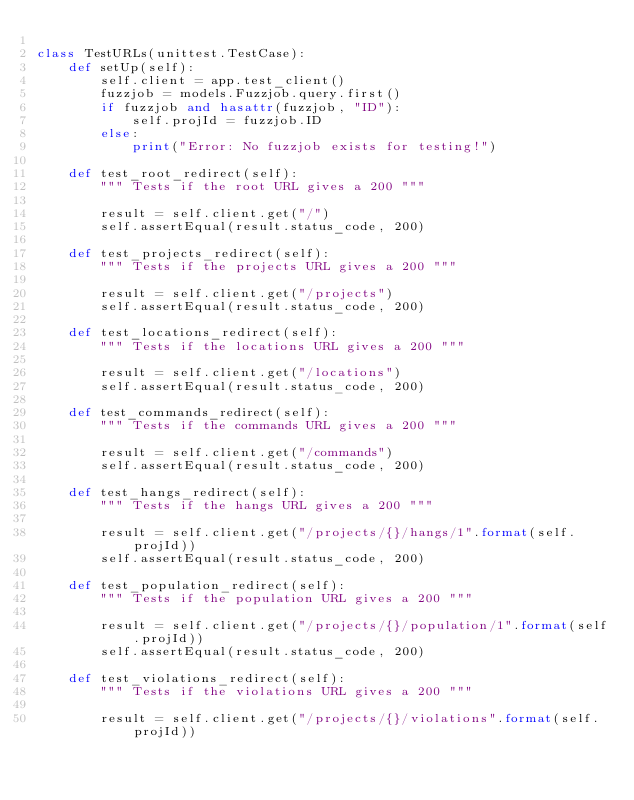Convert code to text. <code><loc_0><loc_0><loc_500><loc_500><_Python_>
class TestURLs(unittest.TestCase):
    def setUp(self):        
        self.client = app.test_client()
        fuzzjob = models.Fuzzjob.query.first()        
        if fuzzjob and hasattr(fuzzjob, "ID"):
            self.projId = fuzzjob.ID
        else:
            print("Error: No fuzzjob exists for testing!")            

    def test_root_redirect(self):
        """ Tests if the root URL gives a 200 """

        result = self.client.get("/")
        self.assertEqual(result.status_code, 200)  
        
    def test_projects_redirect(self):
        """ Tests if the projects URL gives a 200 """

        result = self.client.get("/projects")
        self.assertEqual(result.status_code, 200)  

    def test_locations_redirect(self):
        """ Tests if the locations URL gives a 200 """

        result = self.client.get("/locations")
        self.assertEqual(result.status_code, 200)  

    def test_commands_redirect(self):
        """ Tests if the commands URL gives a 200 """

        result = self.client.get("/commands")
        self.assertEqual(result.status_code, 200) 

    def test_hangs_redirect(self):
        """ Tests if the hangs URL gives a 200 """

        result = self.client.get("/projects/{}/hangs/1".format(self.projId))
        self.assertEqual(result.status_code, 200)  

    def test_population_redirect(self):
        """ Tests if the population URL gives a 200 """

        result = self.client.get("/projects/{}/population/1".format(self.projId))
        self.assertEqual(result.status_code, 200)  

    def test_violations_redirect(self):
        """ Tests if the violations URL gives a 200 """

        result = self.client.get("/projects/{}/violations".format(self.projId))</code> 